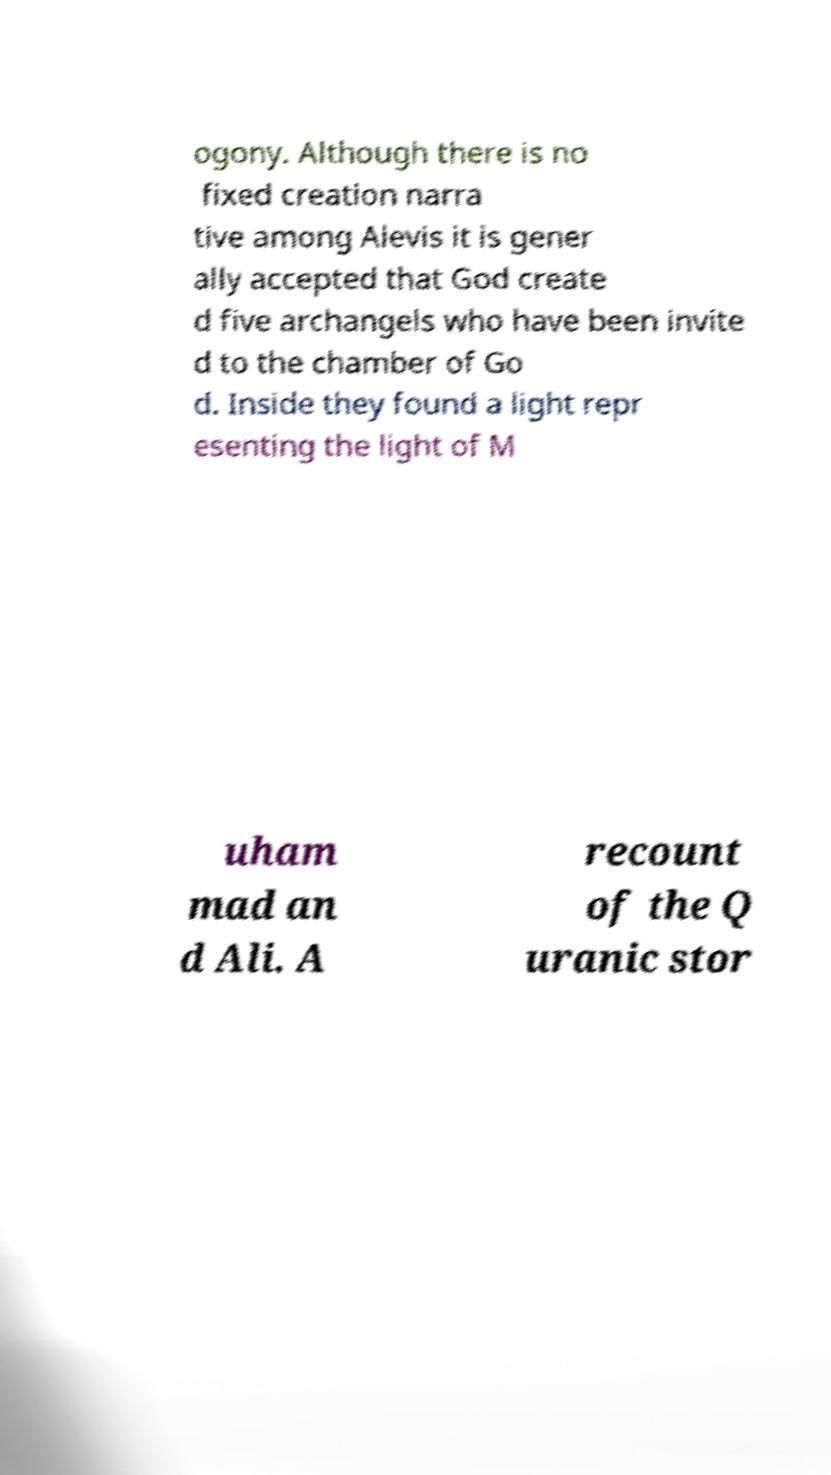Can you read and provide the text displayed in the image?This photo seems to have some interesting text. Can you extract and type it out for me? ogony. Although there is no fixed creation narra tive among Alevis it is gener ally accepted that God create d five archangels who have been invite d to the chamber of Go d. Inside they found a light repr esenting the light of M uham mad an d Ali. A recount of the Q uranic stor 